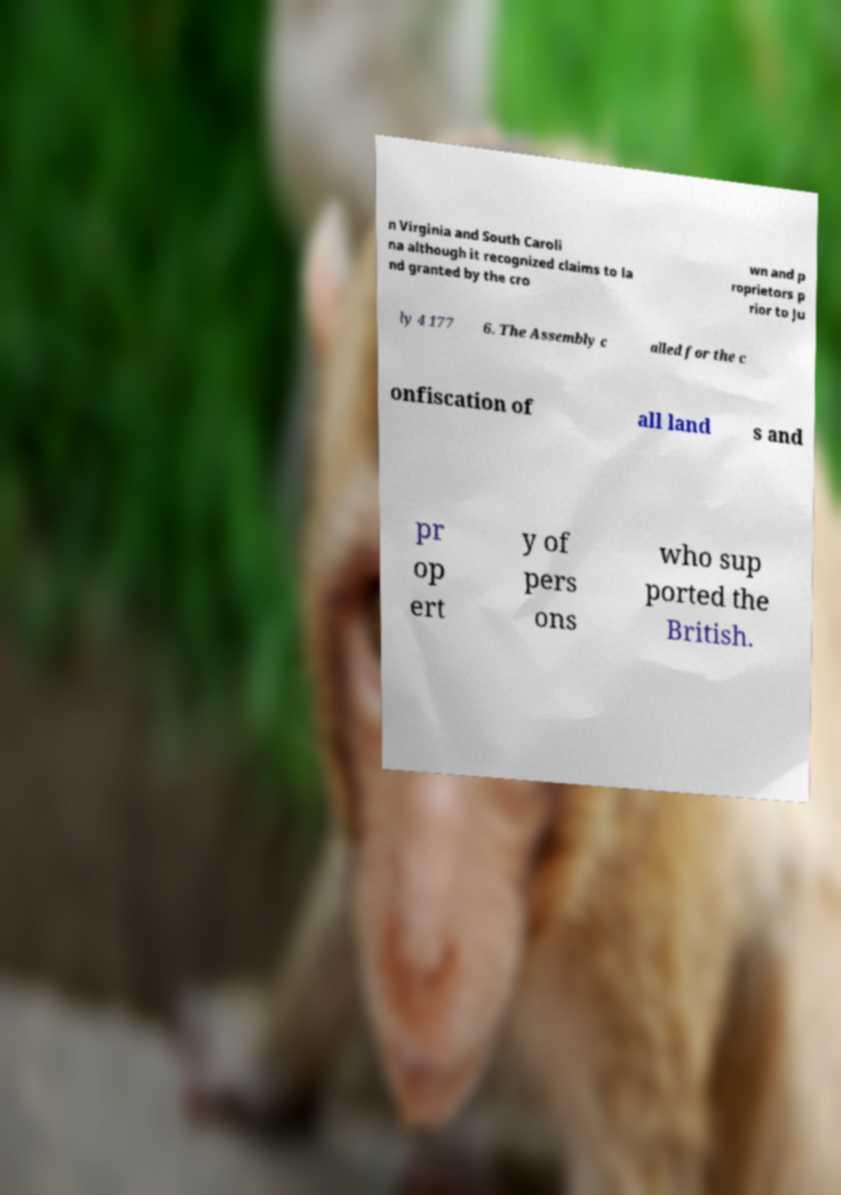Can you read and provide the text displayed in the image?This photo seems to have some interesting text. Can you extract and type it out for me? n Virginia and South Caroli na although it recognized claims to la nd granted by the cro wn and p roprietors p rior to Ju ly 4 177 6. The Assembly c alled for the c onfiscation of all land s and pr op ert y of pers ons who sup ported the British. 